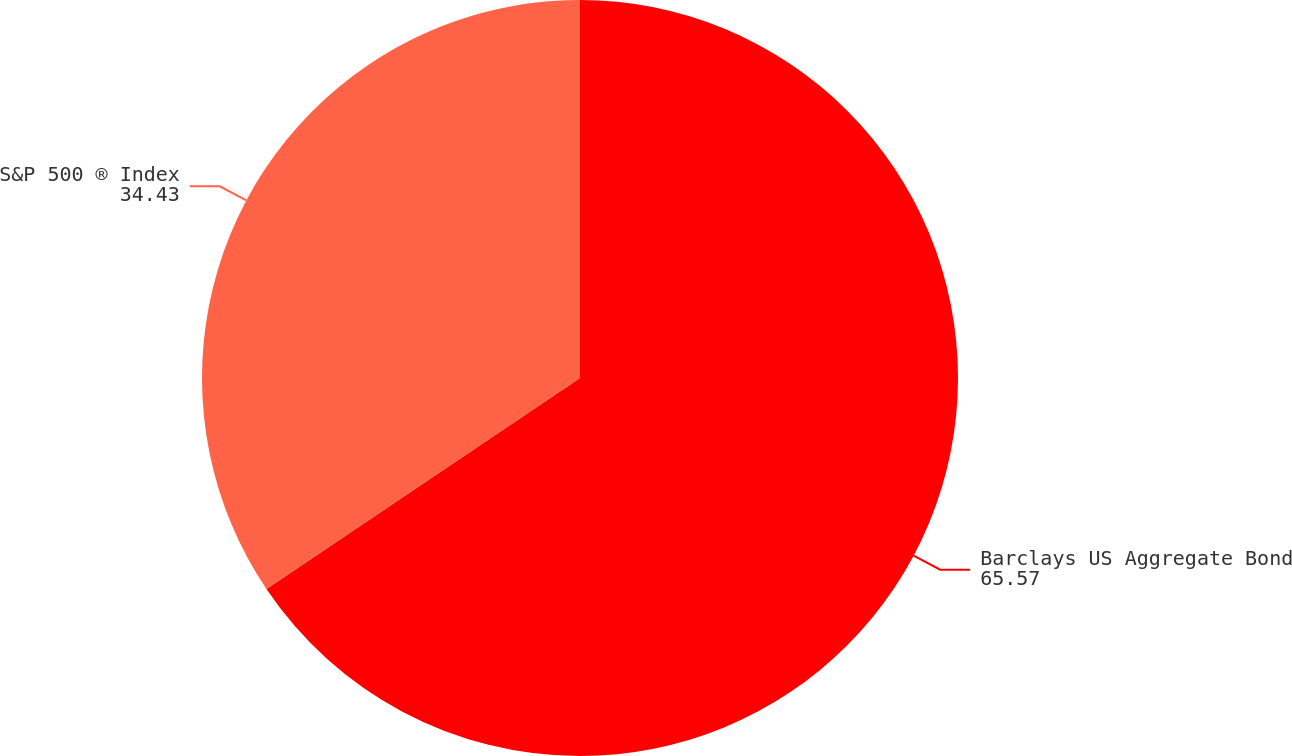<chart> <loc_0><loc_0><loc_500><loc_500><pie_chart><fcel>Barclays US Aggregate Bond<fcel>S&P 500 ® Index<nl><fcel>65.57%<fcel>34.43%<nl></chart> 